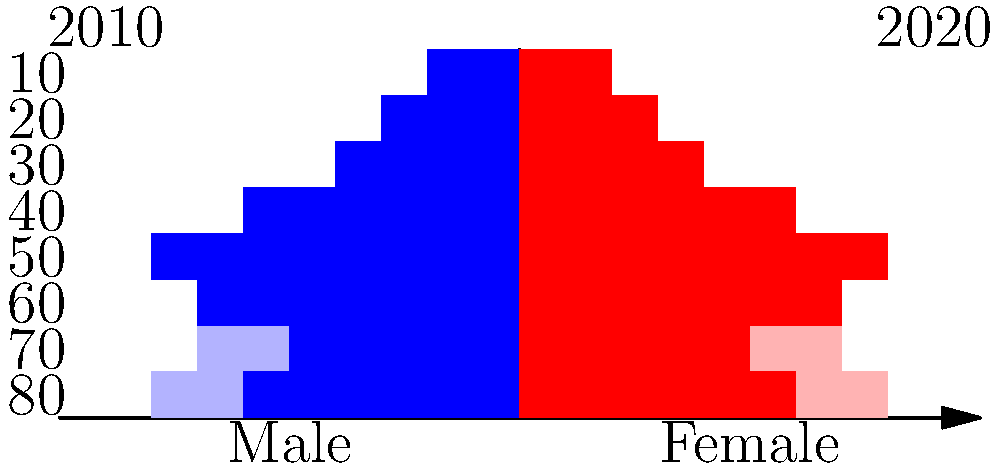As a long-time resident of Wangsiying Area, you've witnessed demographic changes over the years. The population pyramids above show the age structure of Wangsiying Area in 2010 (lighter colors) and 2020 (darker colors). Based on these pyramids, what significant demographic shift has occurred in the area between 2010 and 2020, and what might be a potential cause for this change? To analyze the demographic shift in Wangsiying Area between 2010 and 2020, let's examine the population pyramids step-by-step:

1. Shape change: The 2010 pyramid (lighter colors) shows a more traditional pyramid shape, while the 2020 pyramid (darker colors) has a distinct bulge in the middle.

2. Age group changes:
   a) 0-20 age group (bottom two bars): Decreased from 2010 to 2020
   b) 20-40 age group (next two bars): Significantly increased from 2010 to 2020
   c) 40-60 age group (middle two bars): Slight increase
   d) 60+ age group (top two bars): Relatively stable

3. Main observation: There's a notable increase in the 20-40 age group, forming a bulge in the 2020 pyramid.

4. Potential cause: This shift suggests an influx of young adults into Wangsiying Area between 2010 and 2020. As a retired elderly man living in the area, you might have noticed more young people moving in.

5. Possible explanations for this influx:
   a) Urban development: New job opportunities attracting young professionals
   b) Housing developments: Affordable housing options for young families
   c) Education or training centers: Establishment of institutions drawing young adults
   d) Tech or industrial parks: Creation of employment hubs for skilled young workers

The demographic shift indicates that Wangsiying Area has become more attractive to young adults, potentially due to economic or urban development factors.
Answer: Significant increase in young adult population (20-40 age group), likely due to urban development and job opportunities. 